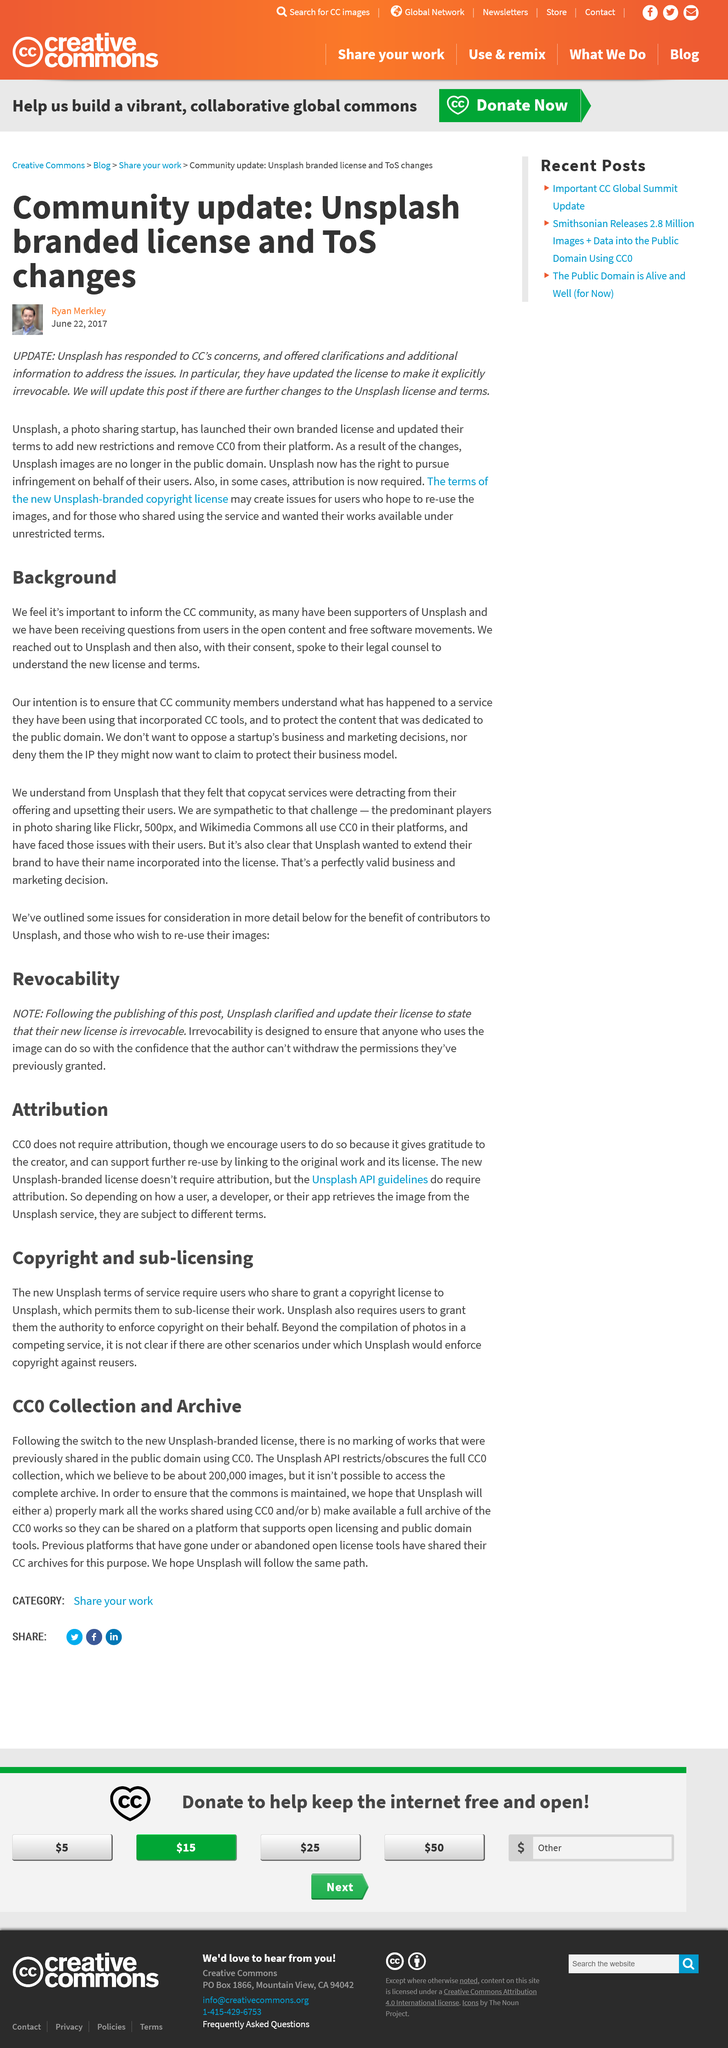Draw attention to some important aspects in this diagram. CC0 is a tool that allows for the release of creative works into the public domain by declaring them to be in the public domain, which means that they are free to use and adapt without any restrictions or attribution required. This allows for the easy sharing and reuse of these works on platforms that support open licensing and public domain tools. Unsplash is a photo sharing startup that is a type of business. It is important to inform the CC community because it is necessary to address the questions and concerns of users in the open content and free software movements. Ryan Merkley wrote the article. There are 200,000 CC0 images in the collection. 